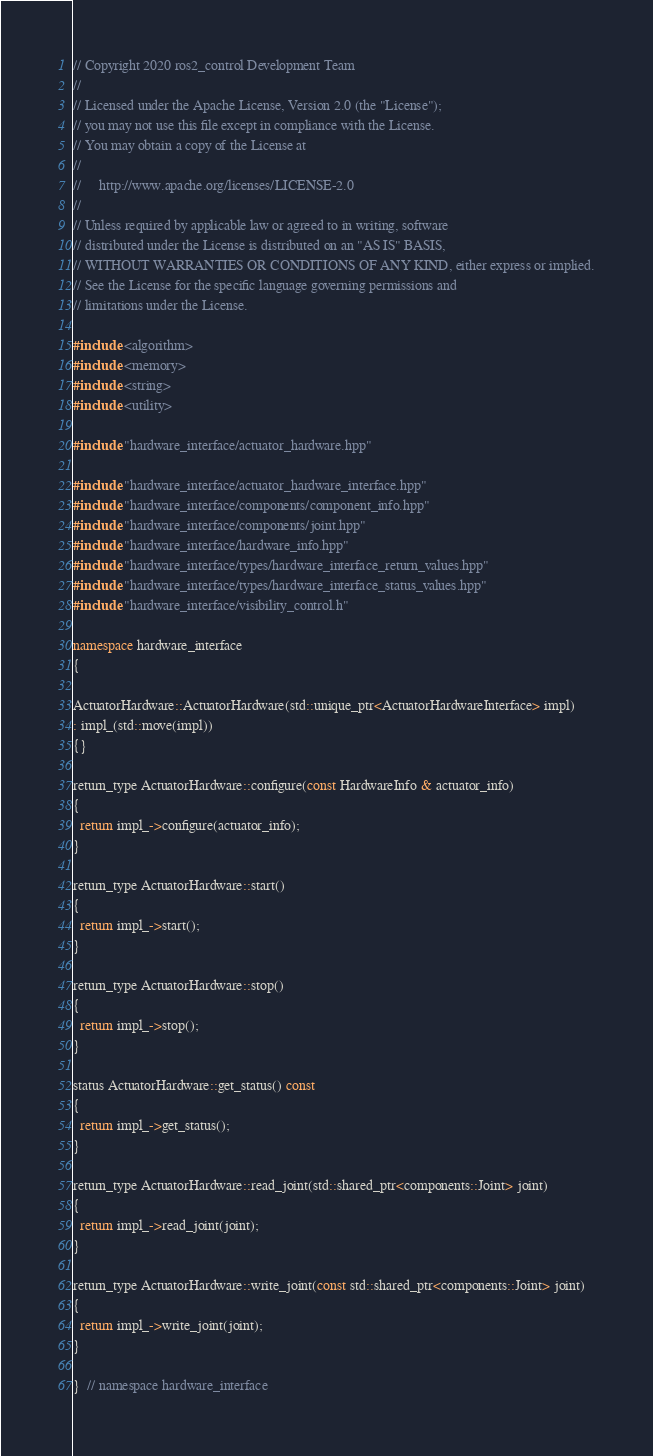Convert code to text. <code><loc_0><loc_0><loc_500><loc_500><_C++_>// Copyright 2020 ros2_control Development Team
//
// Licensed under the Apache License, Version 2.0 (the "License");
// you may not use this file except in compliance with the License.
// You may obtain a copy of the License at
//
//     http://www.apache.org/licenses/LICENSE-2.0
//
// Unless required by applicable law or agreed to in writing, software
// distributed under the License is distributed on an "AS IS" BASIS,
// WITHOUT WARRANTIES OR CONDITIONS OF ANY KIND, either express or implied.
// See the License for the specific language governing permissions and
// limitations under the License.

#include <algorithm>
#include <memory>
#include <string>
#include <utility>

#include "hardware_interface/actuator_hardware.hpp"

#include "hardware_interface/actuator_hardware_interface.hpp"
#include "hardware_interface/components/component_info.hpp"
#include "hardware_interface/components/joint.hpp"
#include "hardware_interface/hardware_info.hpp"
#include "hardware_interface/types/hardware_interface_return_values.hpp"
#include "hardware_interface/types/hardware_interface_status_values.hpp"
#include "hardware_interface/visibility_control.h"

namespace hardware_interface
{

ActuatorHardware::ActuatorHardware(std::unique_ptr<ActuatorHardwareInterface> impl)
: impl_(std::move(impl))
{}

return_type ActuatorHardware::configure(const HardwareInfo & actuator_info)
{
  return impl_->configure(actuator_info);
}

return_type ActuatorHardware::start()
{
  return impl_->start();
}

return_type ActuatorHardware::stop()
{
  return impl_->stop();
}

status ActuatorHardware::get_status() const
{
  return impl_->get_status();
}

return_type ActuatorHardware::read_joint(std::shared_ptr<components::Joint> joint)
{
  return impl_->read_joint(joint);
}

return_type ActuatorHardware::write_joint(const std::shared_ptr<components::Joint> joint)
{
  return impl_->write_joint(joint);
}

}  // namespace hardware_interface
</code> 